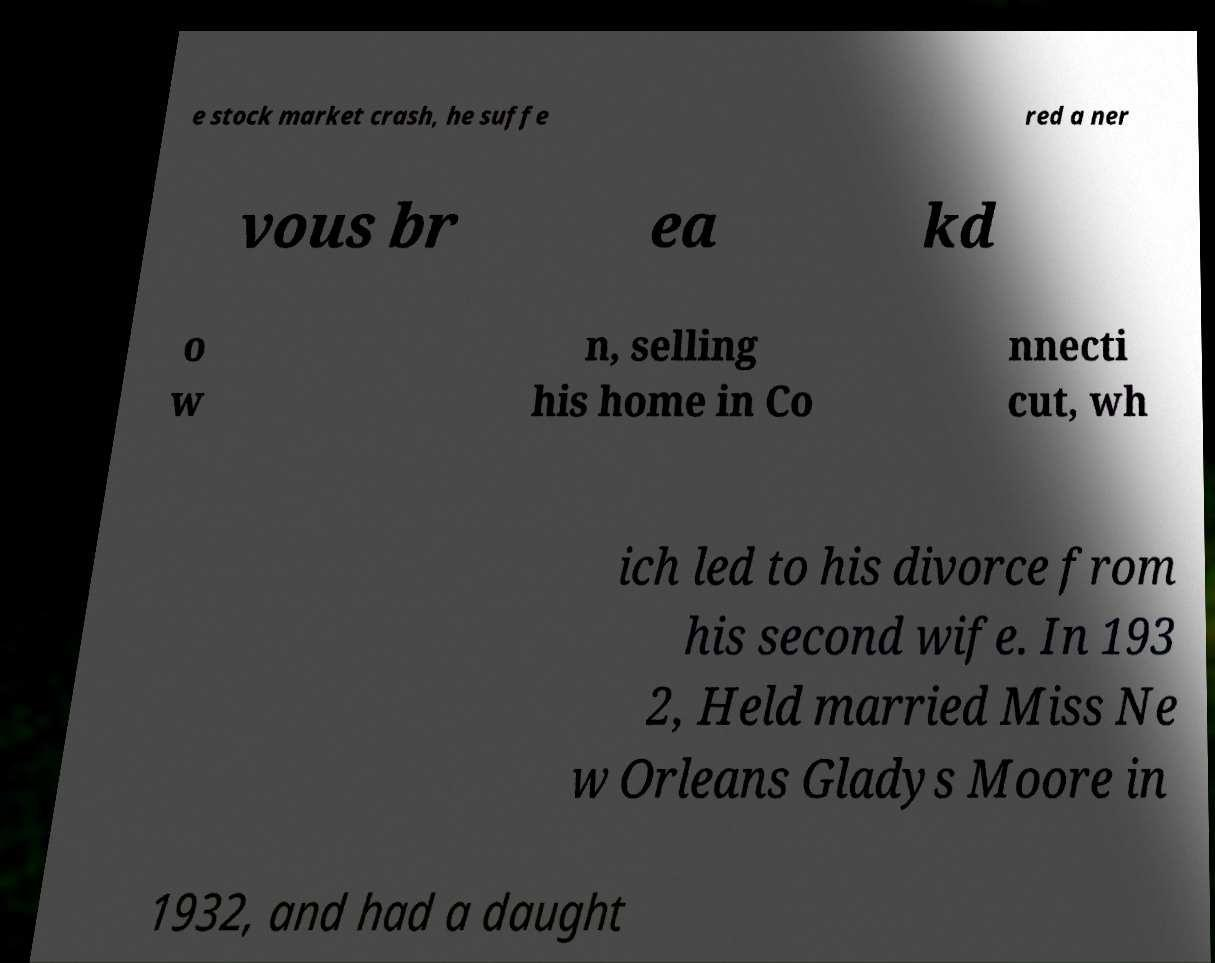I need the written content from this picture converted into text. Can you do that? e stock market crash, he suffe red a ner vous br ea kd o w n, selling his home in Co nnecti cut, wh ich led to his divorce from his second wife. In 193 2, Held married Miss Ne w Orleans Gladys Moore in 1932, and had a daught 